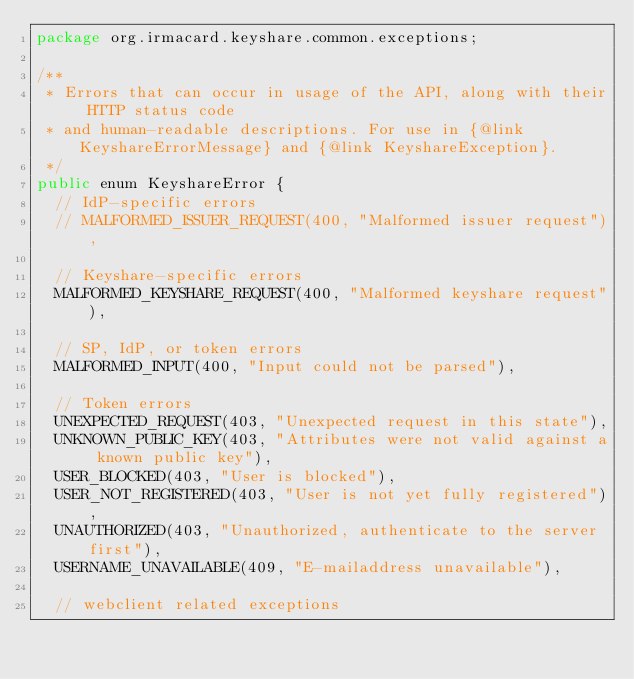<code> <loc_0><loc_0><loc_500><loc_500><_Java_>package org.irmacard.keyshare.common.exceptions;

/**
 * Errors that can occur in usage of the API, along with their HTTP status code
 * and human-readable descriptions. For use in {@link KeyshareErrorMessage} and {@link KeyshareException}.
 */
public enum KeyshareError {
	// IdP-specific errors
	// MALFORMED_ISSUER_REQUEST(400, "Malformed issuer request"),

	// Keyshare-specific errors
	MALFORMED_KEYSHARE_REQUEST(400, "Malformed keyshare request"),

	// SP, IdP, or token errors
	MALFORMED_INPUT(400, "Input could not be parsed"),

	// Token errors
	UNEXPECTED_REQUEST(403, "Unexpected request in this state"),
	UNKNOWN_PUBLIC_KEY(403, "Attributes were not valid against a known public key"),
	USER_BLOCKED(403, "User is blocked"),
	USER_NOT_REGISTERED(403, "User is not yet fully registered"),
	UNAUTHORIZED(403, "Unauthorized, authenticate to the server first"),
	USERNAME_UNAVAILABLE(409, "E-mailaddress unavailable"),

	// webclient related exceptions</code> 